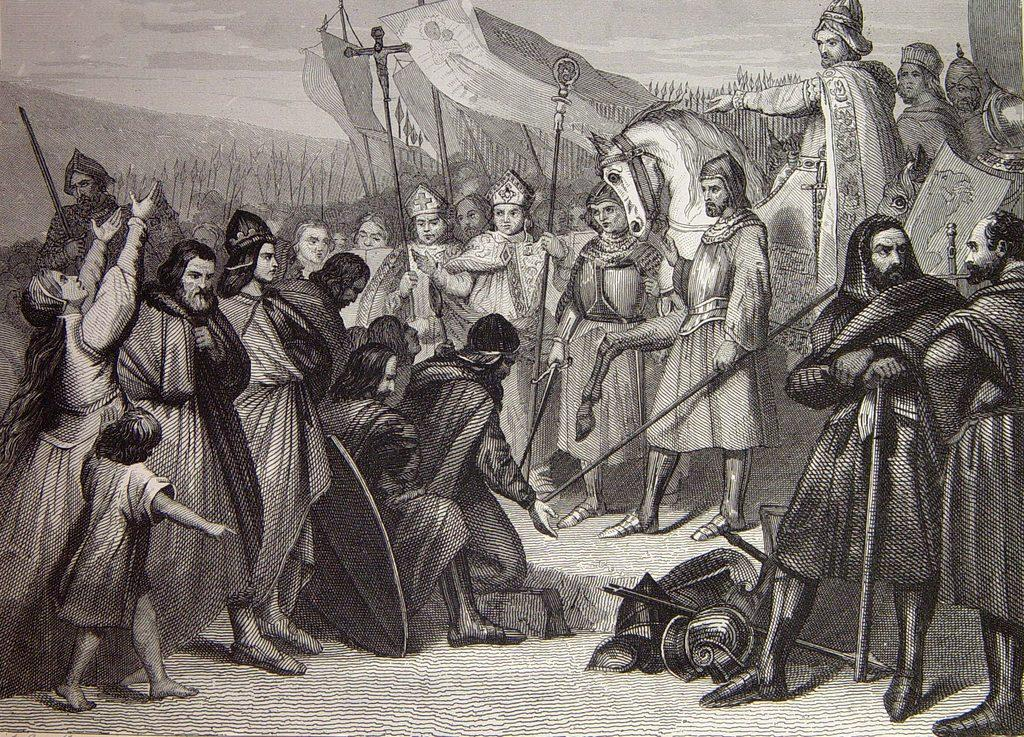What is depicted in the image? There is a sketch of people in the image. What are the people doing in the sketch? The people are standing in the sketch. What are the people holding in their hands? The people are holding objects in their hands. What else can be seen in the image besides the people? There are flags and objects on a surface in the image. How many ants can be seen carrying the objects in the image? There are no ants present in the image; the people are holding the objects. 